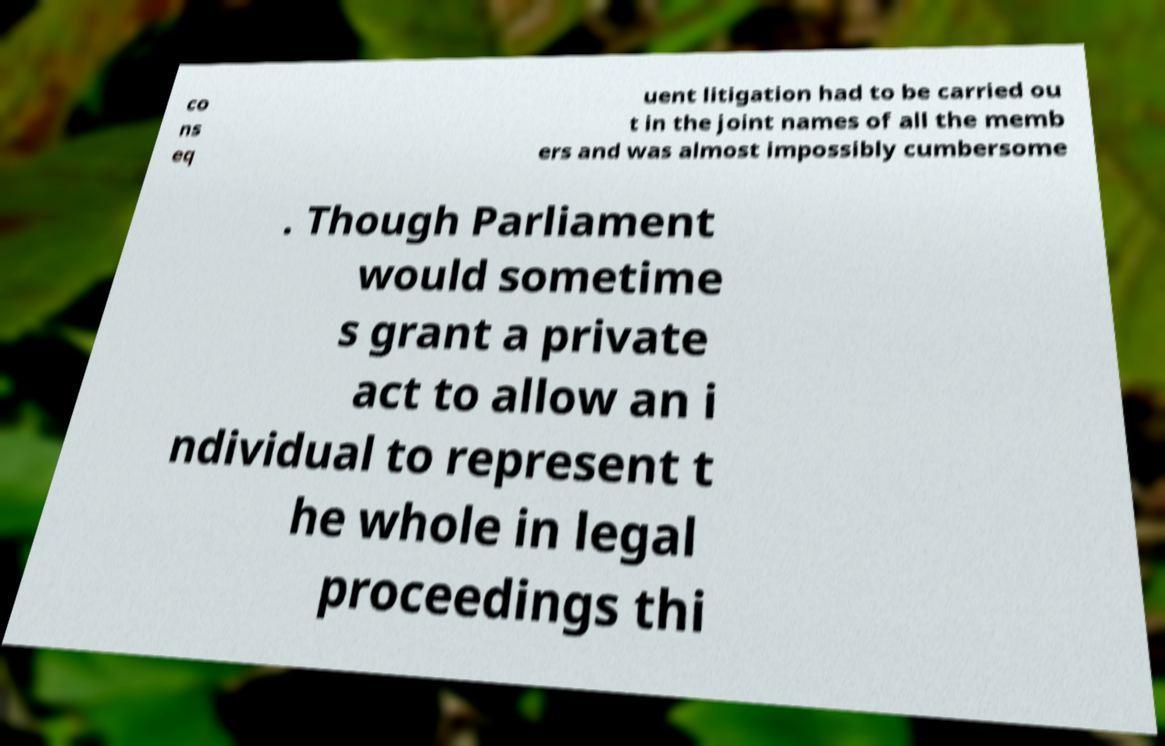Could you assist in decoding the text presented in this image and type it out clearly? co ns eq uent litigation had to be carried ou t in the joint names of all the memb ers and was almost impossibly cumbersome . Though Parliament would sometime s grant a private act to allow an i ndividual to represent t he whole in legal proceedings thi 